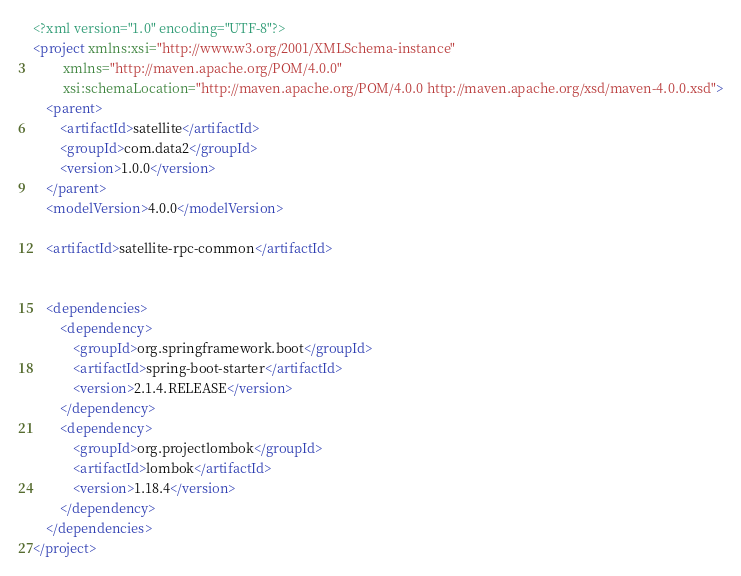<code> <loc_0><loc_0><loc_500><loc_500><_XML_><?xml version="1.0" encoding="UTF-8"?>
<project xmlns:xsi="http://www.w3.org/2001/XMLSchema-instance"
         xmlns="http://maven.apache.org/POM/4.0.0"
         xsi:schemaLocation="http://maven.apache.org/POM/4.0.0 http://maven.apache.org/xsd/maven-4.0.0.xsd">
    <parent>
        <artifactId>satellite</artifactId>
        <groupId>com.data2</groupId>
        <version>1.0.0</version>
    </parent>
    <modelVersion>4.0.0</modelVersion>

    <artifactId>satellite-rpc-common</artifactId>


    <dependencies>
        <dependency>
            <groupId>org.springframework.boot</groupId>
            <artifactId>spring-boot-starter</artifactId>
            <version>2.1.4.RELEASE</version>
        </dependency>
        <dependency>
            <groupId>org.projectlombok</groupId>
            <artifactId>lombok</artifactId>
            <version>1.18.4</version>
        </dependency>
    </dependencies>
</project></code> 